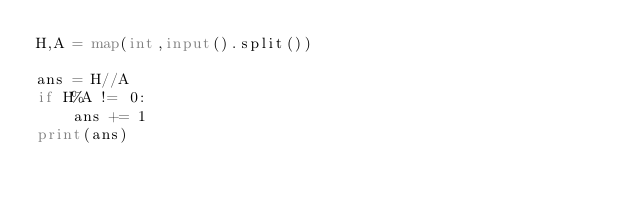Convert code to text. <code><loc_0><loc_0><loc_500><loc_500><_Python_>H,A = map(int,input().split())

ans = H//A
if H%A != 0:
    ans += 1
print(ans)

</code> 